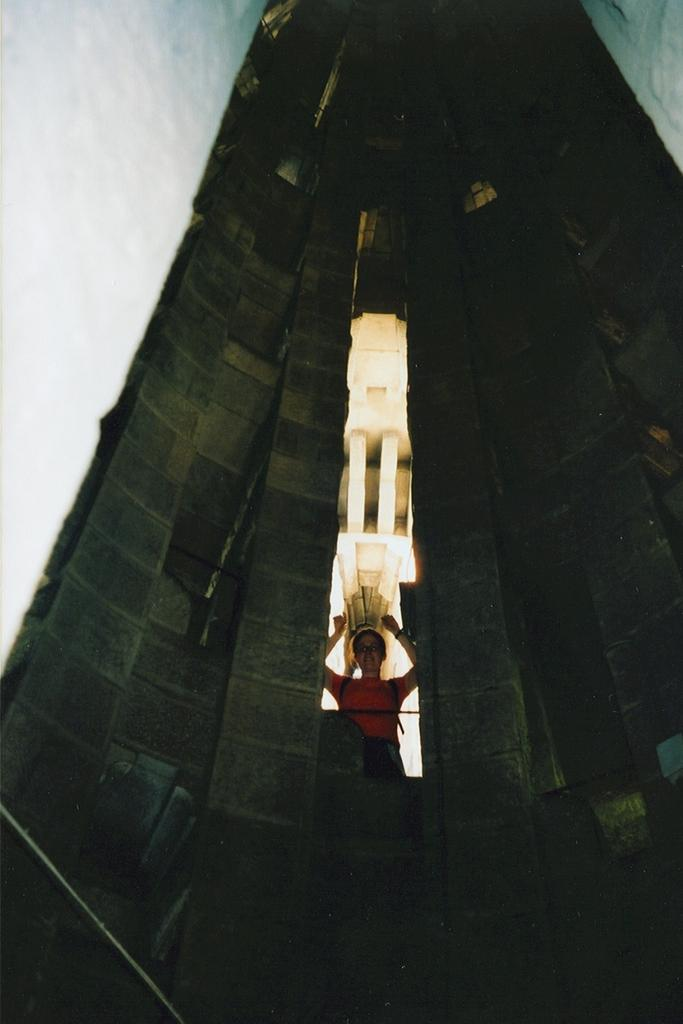What is the main structure in the image? There is a building in the image. Who or what can be seen near the building? There is a lady standing in the image. What can be seen in the distance behind the building? The sky is visible in the background of the image. What time of day is it in the image, and is the lady a beginner at something? The time of day cannot be determined from the image, and there is no information about the lady being a beginner at anything. 